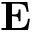<formula> <loc_0><loc_0><loc_500><loc_500>E</formula> 